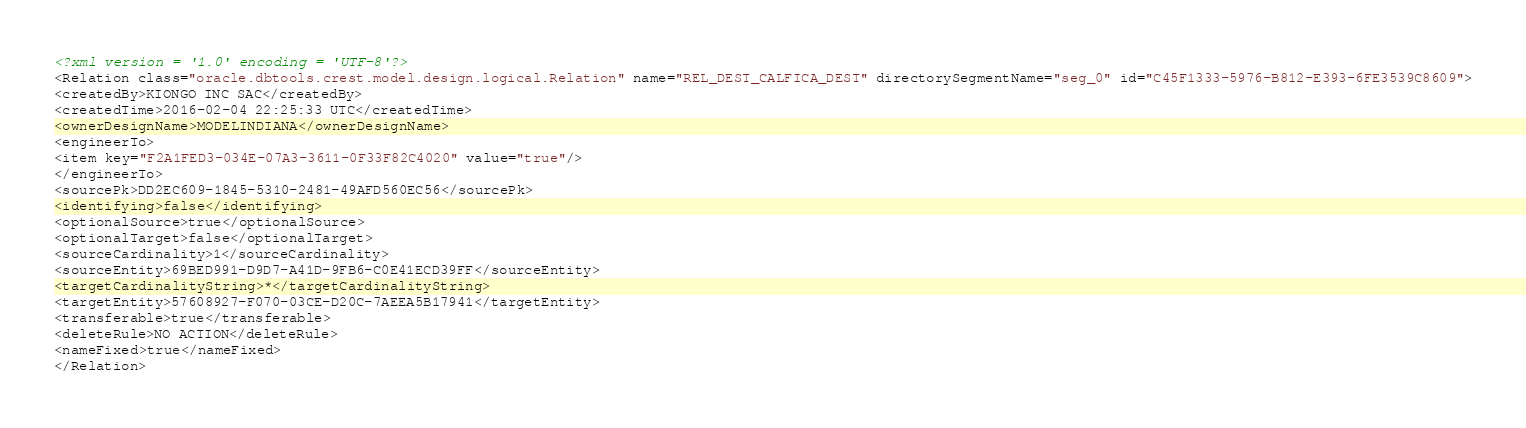<code> <loc_0><loc_0><loc_500><loc_500><_XML_><?xml version = '1.0' encoding = 'UTF-8'?>
<Relation class="oracle.dbtools.crest.model.design.logical.Relation" name="REL_DEST_CALFICA_DEST" directorySegmentName="seg_0" id="C45F1333-5976-B812-E393-6FE3539C8609">
<createdBy>KIONGO INC SAC</createdBy>
<createdTime>2016-02-04 22:25:33 UTC</createdTime>
<ownerDesignName>MODELINDIANA</ownerDesignName>
<engineerTo>
<item key="F2A1FED3-034E-07A3-3611-0F33F82C4020" value="true"/>
</engineerTo>
<sourcePk>DD2EC609-1845-5310-2481-49AFD560EC56</sourcePk>
<identifying>false</identifying>
<optionalSource>true</optionalSource>
<optionalTarget>false</optionalTarget>
<sourceCardinality>1</sourceCardinality>
<sourceEntity>69BED991-D9D7-A41D-9FB6-C0E41ECD39FF</sourceEntity>
<targetCardinalityString>*</targetCardinalityString>
<targetEntity>57608927-F070-03CE-D20C-7AEEA5B17941</targetEntity>
<transferable>true</transferable>
<deleteRule>NO ACTION</deleteRule>
<nameFixed>true</nameFixed>
</Relation></code> 